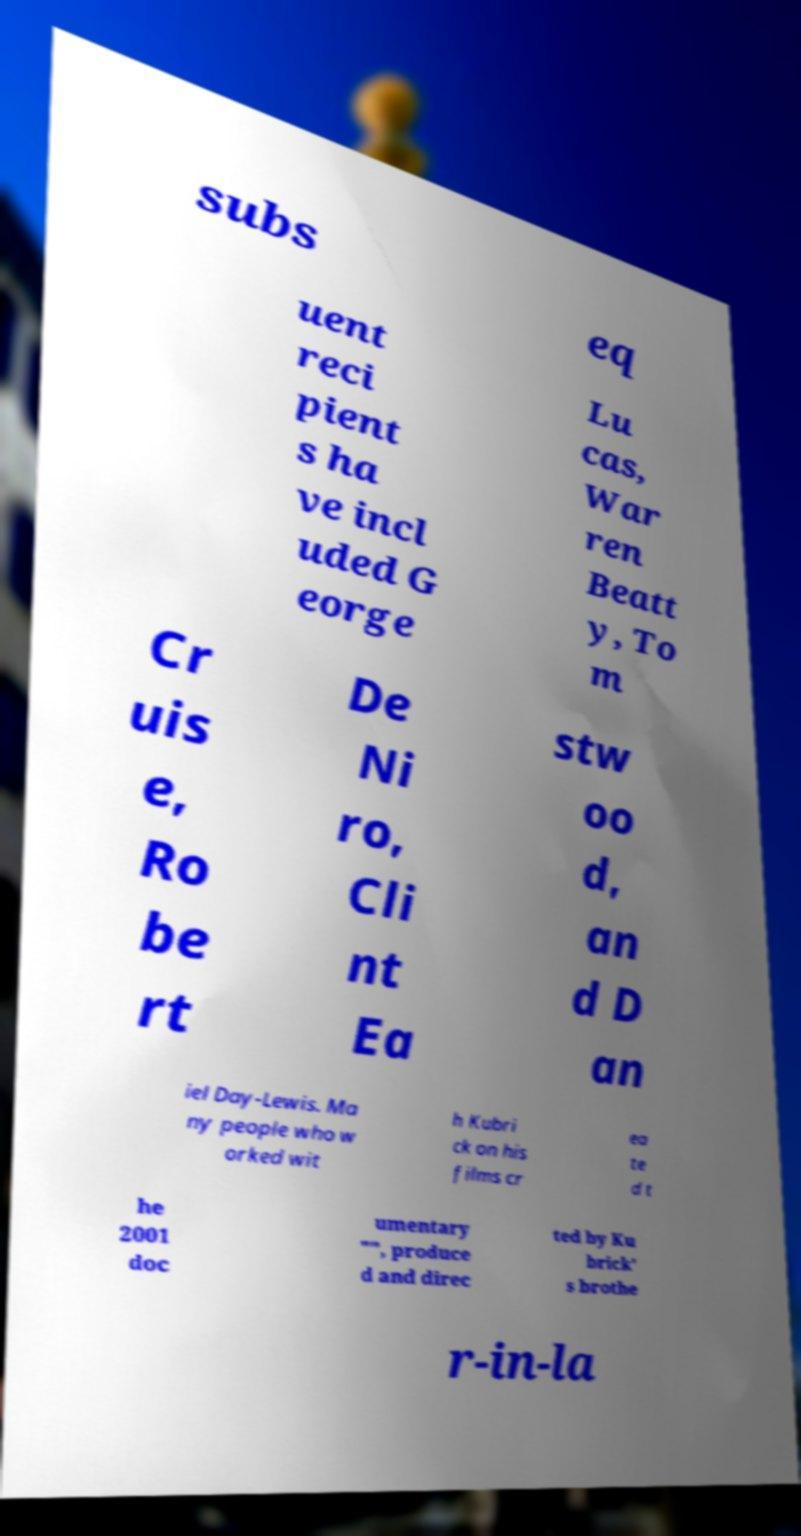I need the written content from this picture converted into text. Can you do that? subs eq uent reci pient s ha ve incl uded G eorge Lu cas, War ren Beatt y, To m Cr uis e, Ro be rt De Ni ro, Cli nt Ea stw oo d, an d D an iel Day-Lewis. Ma ny people who w orked wit h Kubri ck on his films cr ea te d t he 2001 doc umentary "", produce d and direc ted by Ku brick' s brothe r-in-la 